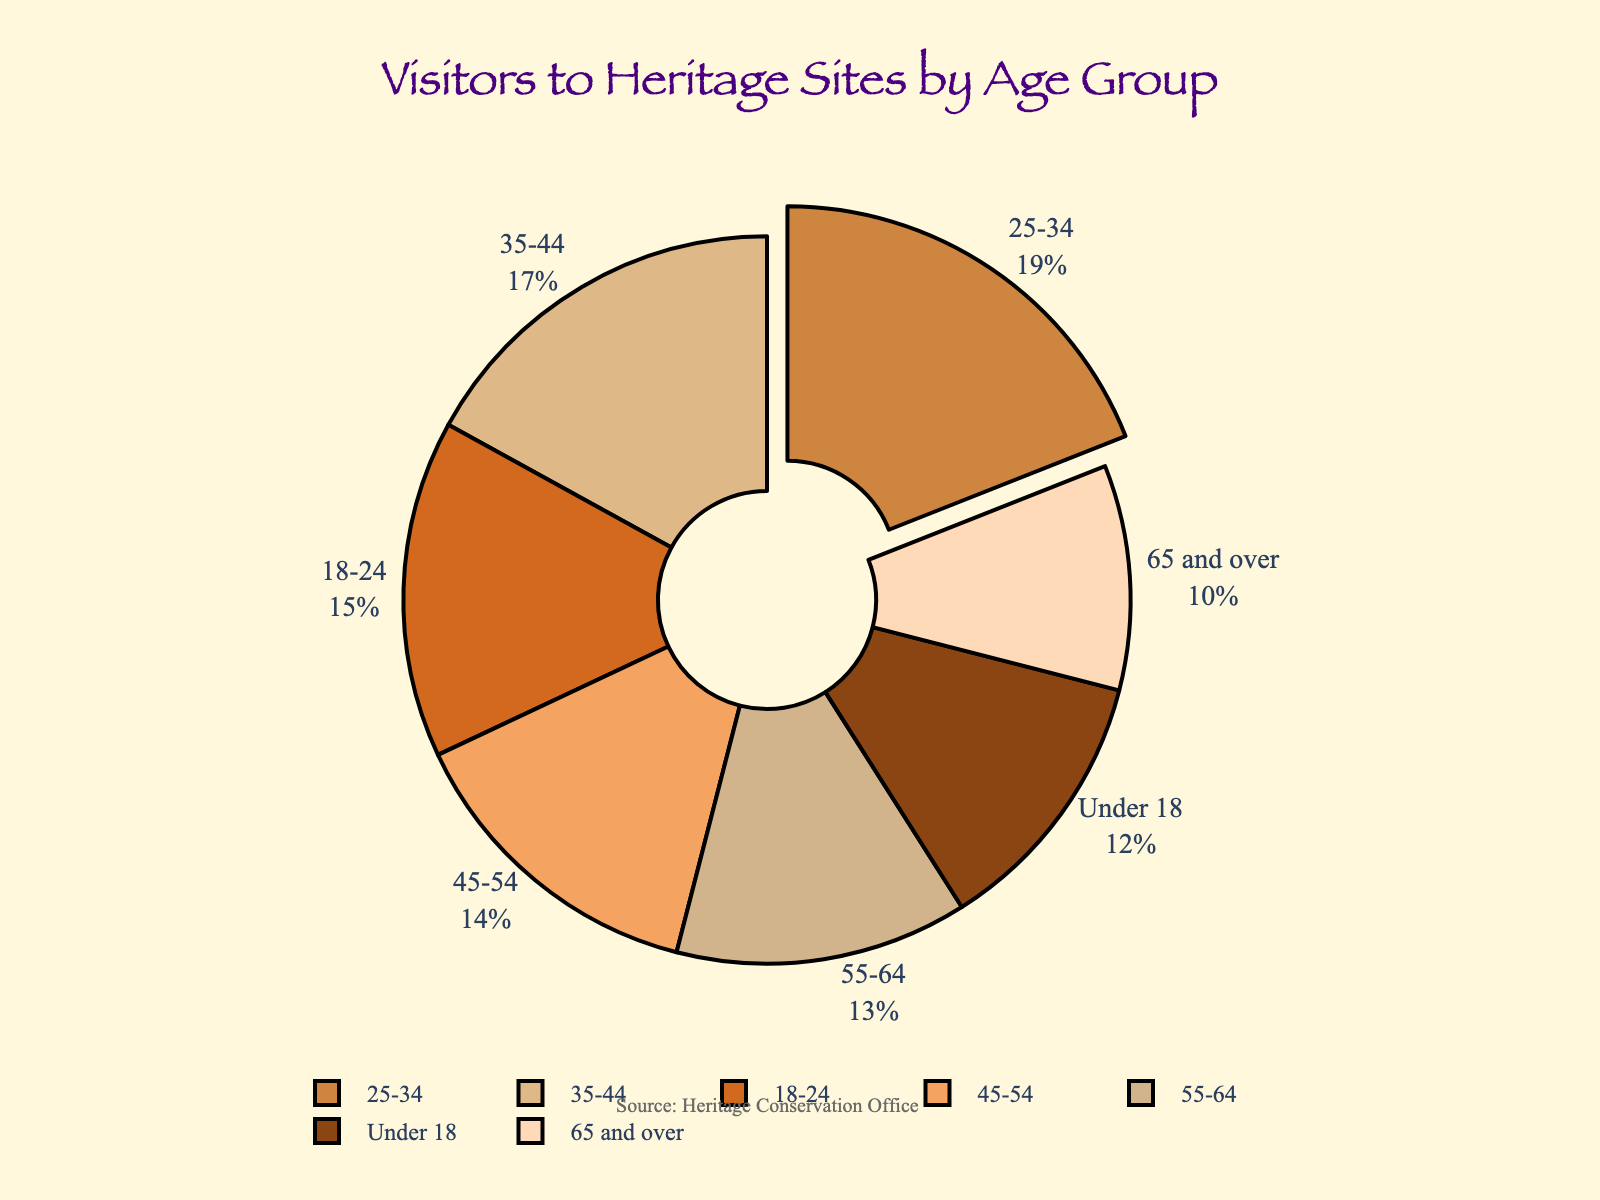What is the percentage of visitors aged 25-34? The pie chart shows the labels and percentages of each age group. Find the "25-34" label and read the percentage associated with it.
Answer: 19% Which age group has the smallest percentage of visitors? The pie chart shows different age groups and percentages. Look for the age group with the smallest percentage value.
Answer: 65 and over How much greater is the percentage of visitors aged 35-44 compared to those aged 55-64? Find the percentages for the age groups 35-44 and 55-64. Then subtract the percentage of 55-64 from the percentage of 35-44 (17% - 13%).
Answer: 4% Which age group contributes the highest percentage of visitors to heritage sites? Look for the age group label that is pulled out slightly from the pie chart, indicating the highest percentage. Read the percentage value.
Answer: 25-34 What is the combined percentage of visitors aged under 18 and over 65? Find the percentages for the age groups "Under 18" and "65 and over". Add them together (12% + 10%).
Answer: 22% In terms of visual representation, which two age groups have the largest and smallest slice of the pie chart? Locate the slices corresponding to the largest and smallest percentages visually. Compare their sizes.
Answer: Largest: 25-34, Smallest: 65 and over What is the percentage difference between visitors aged 18-24 and those aged 45-54? Find the percentages for the age groups 18-24 and 45-54. Subtract the smaller percentage from the larger one (15% - 14%).
Answer: 1% If the age groups 18-24 and 25-34 are combined, what percentage would they represent together? Add the percentage of visitors aged 18-24 to the percentage of visitors aged 25-34 (15% + 19%).
Answer: 34% What visual cue is used to highlight the age group with the highest percentage of visitors? Observe the design of the pie chart. Look for the attribute (like pulling out the slice) that visually identifies the age group with the highest percentage.
Answer: The slice is pulled out 